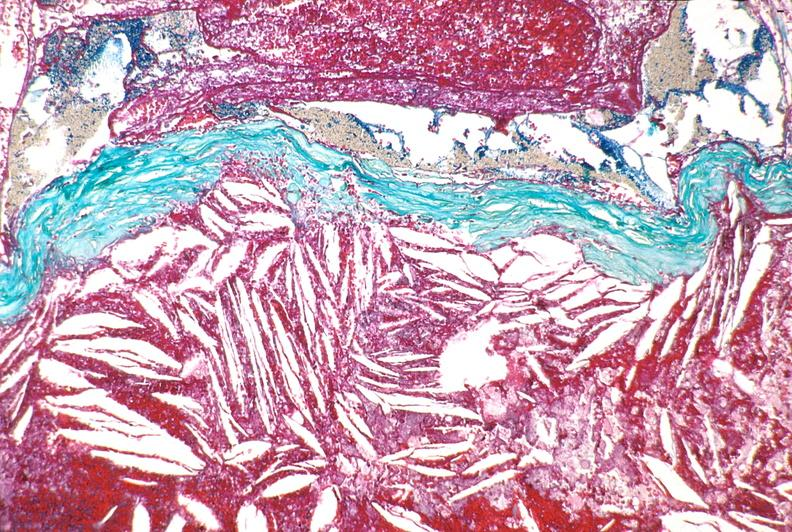does this image show right coronary artery, atherosclerosis and acute thrombus?
Answer the question using a single word or phrase. Yes 